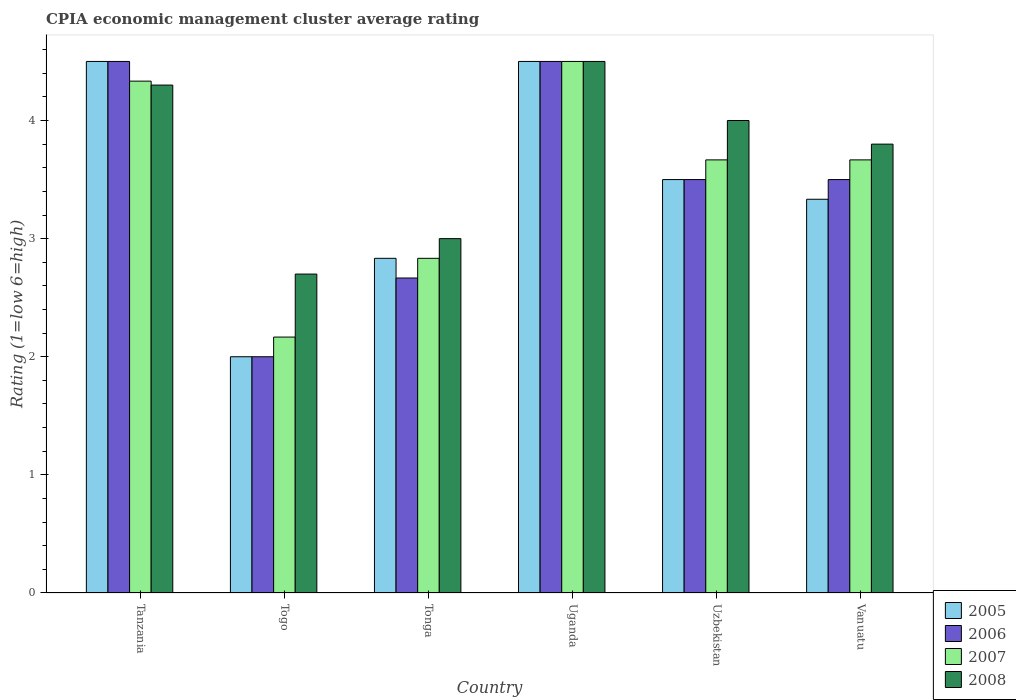How many groups of bars are there?
Give a very brief answer. 6. Are the number of bars per tick equal to the number of legend labels?
Your answer should be very brief. Yes. Are the number of bars on each tick of the X-axis equal?
Ensure brevity in your answer.  Yes. How many bars are there on the 3rd tick from the right?
Give a very brief answer. 4. What is the label of the 5th group of bars from the left?
Offer a terse response. Uzbekistan. What is the CPIA rating in 2005 in Uganda?
Offer a terse response. 4.5. Across all countries, what is the maximum CPIA rating in 2005?
Keep it short and to the point. 4.5. Across all countries, what is the minimum CPIA rating in 2008?
Your answer should be very brief. 2.7. In which country was the CPIA rating in 2006 maximum?
Make the answer very short. Tanzania. In which country was the CPIA rating in 2006 minimum?
Your answer should be compact. Togo. What is the total CPIA rating in 2005 in the graph?
Provide a succinct answer. 20.67. What is the difference between the CPIA rating in 2005 in Tonga and the CPIA rating in 2008 in Tanzania?
Keep it short and to the point. -1.47. What is the average CPIA rating in 2007 per country?
Your response must be concise. 3.53. What is the difference between the CPIA rating of/in 2008 and CPIA rating of/in 2007 in Vanuatu?
Provide a short and direct response. 0.13. What is the ratio of the CPIA rating in 2008 in Uzbekistan to that in Vanuatu?
Your answer should be very brief. 1.05. Is the difference between the CPIA rating in 2008 in Uganda and Vanuatu greater than the difference between the CPIA rating in 2007 in Uganda and Vanuatu?
Give a very brief answer. No. What is the difference between the highest and the lowest CPIA rating in 2007?
Make the answer very short. 2.33. Is the sum of the CPIA rating in 2007 in Togo and Vanuatu greater than the maximum CPIA rating in 2005 across all countries?
Offer a very short reply. Yes. Is it the case that in every country, the sum of the CPIA rating in 2005 and CPIA rating in 2008 is greater than the sum of CPIA rating in 2007 and CPIA rating in 2006?
Offer a very short reply. No. What does the 3rd bar from the right in Uganda represents?
Your answer should be very brief. 2006. How many bars are there?
Offer a very short reply. 24. Are the values on the major ticks of Y-axis written in scientific E-notation?
Give a very brief answer. No. Does the graph contain any zero values?
Offer a terse response. No. Does the graph contain grids?
Provide a succinct answer. No. Where does the legend appear in the graph?
Provide a short and direct response. Bottom right. What is the title of the graph?
Provide a short and direct response. CPIA economic management cluster average rating. Does "1990" appear as one of the legend labels in the graph?
Give a very brief answer. No. What is the label or title of the X-axis?
Give a very brief answer. Country. What is the Rating (1=low 6=high) in 2005 in Tanzania?
Offer a terse response. 4.5. What is the Rating (1=low 6=high) of 2007 in Tanzania?
Keep it short and to the point. 4.33. What is the Rating (1=low 6=high) in 2007 in Togo?
Your answer should be compact. 2.17. What is the Rating (1=low 6=high) of 2008 in Togo?
Give a very brief answer. 2.7. What is the Rating (1=low 6=high) in 2005 in Tonga?
Your answer should be very brief. 2.83. What is the Rating (1=low 6=high) of 2006 in Tonga?
Offer a very short reply. 2.67. What is the Rating (1=low 6=high) of 2007 in Tonga?
Provide a succinct answer. 2.83. What is the Rating (1=low 6=high) in 2005 in Uganda?
Ensure brevity in your answer.  4.5. What is the Rating (1=low 6=high) of 2006 in Uganda?
Offer a terse response. 4.5. What is the Rating (1=low 6=high) in 2005 in Uzbekistan?
Give a very brief answer. 3.5. What is the Rating (1=low 6=high) of 2006 in Uzbekistan?
Give a very brief answer. 3.5. What is the Rating (1=low 6=high) of 2007 in Uzbekistan?
Your response must be concise. 3.67. What is the Rating (1=low 6=high) of 2005 in Vanuatu?
Ensure brevity in your answer.  3.33. What is the Rating (1=low 6=high) of 2007 in Vanuatu?
Your response must be concise. 3.67. Across all countries, what is the maximum Rating (1=low 6=high) in 2006?
Offer a terse response. 4.5. Across all countries, what is the minimum Rating (1=low 6=high) of 2007?
Provide a succinct answer. 2.17. Across all countries, what is the minimum Rating (1=low 6=high) of 2008?
Offer a terse response. 2.7. What is the total Rating (1=low 6=high) of 2005 in the graph?
Make the answer very short. 20.67. What is the total Rating (1=low 6=high) in 2006 in the graph?
Your answer should be compact. 20.67. What is the total Rating (1=low 6=high) in 2007 in the graph?
Your answer should be very brief. 21.17. What is the total Rating (1=low 6=high) in 2008 in the graph?
Provide a short and direct response. 22.3. What is the difference between the Rating (1=low 6=high) of 2007 in Tanzania and that in Togo?
Make the answer very short. 2.17. What is the difference between the Rating (1=low 6=high) of 2008 in Tanzania and that in Togo?
Your answer should be very brief. 1.6. What is the difference between the Rating (1=low 6=high) in 2005 in Tanzania and that in Tonga?
Ensure brevity in your answer.  1.67. What is the difference between the Rating (1=low 6=high) of 2006 in Tanzania and that in Tonga?
Provide a short and direct response. 1.83. What is the difference between the Rating (1=low 6=high) of 2008 in Tanzania and that in Tonga?
Offer a terse response. 1.3. What is the difference between the Rating (1=low 6=high) of 2007 in Tanzania and that in Uganda?
Make the answer very short. -0.17. What is the difference between the Rating (1=low 6=high) in 2008 in Tanzania and that in Uganda?
Your response must be concise. -0.2. What is the difference between the Rating (1=low 6=high) of 2005 in Tanzania and that in Uzbekistan?
Offer a terse response. 1. What is the difference between the Rating (1=low 6=high) of 2008 in Tanzania and that in Uzbekistan?
Ensure brevity in your answer.  0.3. What is the difference between the Rating (1=low 6=high) in 2006 in Togo and that in Tonga?
Your answer should be compact. -0.67. What is the difference between the Rating (1=low 6=high) in 2007 in Togo and that in Uganda?
Keep it short and to the point. -2.33. What is the difference between the Rating (1=low 6=high) in 2006 in Togo and that in Uzbekistan?
Keep it short and to the point. -1.5. What is the difference between the Rating (1=low 6=high) in 2007 in Togo and that in Uzbekistan?
Your response must be concise. -1.5. What is the difference between the Rating (1=low 6=high) of 2008 in Togo and that in Uzbekistan?
Give a very brief answer. -1.3. What is the difference between the Rating (1=low 6=high) in 2005 in Togo and that in Vanuatu?
Ensure brevity in your answer.  -1.33. What is the difference between the Rating (1=low 6=high) in 2006 in Togo and that in Vanuatu?
Provide a short and direct response. -1.5. What is the difference between the Rating (1=low 6=high) of 2005 in Tonga and that in Uganda?
Ensure brevity in your answer.  -1.67. What is the difference between the Rating (1=low 6=high) in 2006 in Tonga and that in Uganda?
Offer a very short reply. -1.83. What is the difference between the Rating (1=low 6=high) of 2007 in Tonga and that in Uganda?
Your response must be concise. -1.67. What is the difference between the Rating (1=low 6=high) in 2008 in Tonga and that in Uganda?
Give a very brief answer. -1.5. What is the difference between the Rating (1=low 6=high) of 2007 in Tonga and that in Uzbekistan?
Your answer should be very brief. -0.83. What is the difference between the Rating (1=low 6=high) in 2005 in Tonga and that in Vanuatu?
Keep it short and to the point. -0.5. What is the difference between the Rating (1=low 6=high) of 2006 in Tonga and that in Vanuatu?
Ensure brevity in your answer.  -0.83. What is the difference between the Rating (1=low 6=high) of 2007 in Tonga and that in Vanuatu?
Your answer should be very brief. -0.83. What is the difference between the Rating (1=low 6=high) of 2006 in Uganda and that in Uzbekistan?
Your response must be concise. 1. What is the difference between the Rating (1=low 6=high) in 2008 in Uganda and that in Uzbekistan?
Offer a very short reply. 0.5. What is the difference between the Rating (1=low 6=high) in 2005 in Uganda and that in Vanuatu?
Provide a succinct answer. 1.17. What is the difference between the Rating (1=low 6=high) in 2007 in Uganda and that in Vanuatu?
Ensure brevity in your answer.  0.83. What is the difference between the Rating (1=low 6=high) in 2005 in Tanzania and the Rating (1=low 6=high) in 2007 in Togo?
Give a very brief answer. 2.33. What is the difference between the Rating (1=low 6=high) in 2006 in Tanzania and the Rating (1=low 6=high) in 2007 in Togo?
Ensure brevity in your answer.  2.33. What is the difference between the Rating (1=low 6=high) in 2007 in Tanzania and the Rating (1=low 6=high) in 2008 in Togo?
Your answer should be very brief. 1.63. What is the difference between the Rating (1=low 6=high) of 2005 in Tanzania and the Rating (1=low 6=high) of 2006 in Tonga?
Your answer should be very brief. 1.83. What is the difference between the Rating (1=low 6=high) in 2006 in Tanzania and the Rating (1=low 6=high) in 2007 in Tonga?
Provide a short and direct response. 1.67. What is the difference between the Rating (1=low 6=high) of 2006 in Tanzania and the Rating (1=low 6=high) of 2008 in Tonga?
Offer a very short reply. 1.5. What is the difference between the Rating (1=low 6=high) of 2007 in Tanzania and the Rating (1=low 6=high) of 2008 in Tonga?
Provide a succinct answer. 1.33. What is the difference between the Rating (1=low 6=high) in 2005 in Tanzania and the Rating (1=low 6=high) in 2006 in Uganda?
Provide a short and direct response. 0. What is the difference between the Rating (1=low 6=high) in 2006 in Tanzania and the Rating (1=low 6=high) in 2007 in Uganda?
Ensure brevity in your answer.  0. What is the difference between the Rating (1=low 6=high) in 2005 in Tanzania and the Rating (1=low 6=high) in 2006 in Uzbekistan?
Your answer should be very brief. 1. What is the difference between the Rating (1=low 6=high) of 2005 in Tanzania and the Rating (1=low 6=high) of 2008 in Uzbekistan?
Ensure brevity in your answer.  0.5. What is the difference between the Rating (1=low 6=high) of 2006 in Tanzania and the Rating (1=low 6=high) of 2008 in Uzbekistan?
Your answer should be compact. 0.5. What is the difference between the Rating (1=low 6=high) of 2005 in Tanzania and the Rating (1=low 6=high) of 2008 in Vanuatu?
Provide a succinct answer. 0.7. What is the difference between the Rating (1=low 6=high) in 2006 in Tanzania and the Rating (1=low 6=high) in 2008 in Vanuatu?
Keep it short and to the point. 0.7. What is the difference between the Rating (1=low 6=high) of 2007 in Tanzania and the Rating (1=low 6=high) of 2008 in Vanuatu?
Provide a short and direct response. 0.53. What is the difference between the Rating (1=low 6=high) in 2005 in Togo and the Rating (1=low 6=high) in 2006 in Tonga?
Make the answer very short. -0.67. What is the difference between the Rating (1=low 6=high) of 2005 in Togo and the Rating (1=low 6=high) of 2007 in Tonga?
Provide a succinct answer. -0.83. What is the difference between the Rating (1=low 6=high) of 2007 in Togo and the Rating (1=low 6=high) of 2008 in Tonga?
Ensure brevity in your answer.  -0.83. What is the difference between the Rating (1=low 6=high) in 2005 in Togo and the Rating (1=low 6=high) in 2008 in Uganda?
Your response must be concise. -2.5. What is the difference between the Rating (1=low 6=high) in 2007 in Togo and the Rating (1=low 6=high) in 2008 in Uganda?
Your response must be concise. -2.33. What is the difference between the Rating (1=low 6=high) in 2005 in Togo and the Rating (1=low 6=high) in 2006 in Uzbekistan?
Give a very brief answer. -1.5. What is the difference between the Rating (1=low 6=high) in 2005 in Togo and the Rating (1=low 6=high) in 2007 in Uzbekistan?
Your answer should be very brief. -1.67. What is the difference between the Rating (1=low 6=high) of 2005 in Togo and the Rating (1=low 6=high) of 2008 in Uzbekistan?
Your answer should be very brief. -2. What is the difference between the Rating (1=low 6=high) in 2006 in Togo and the Rating (1=low 6=high) in 2007 in Uzbekistan?
Give a very brief answer. -1.67. What is the difference between the Rating (1=low 6=high) in 2006 in Togo and the Rating (1=low 6=high) in 2008 in Uzbekistan?
Your answer should be very brief. -2. What is the difference between the Rating (1=low 6=high) of 2007 in Togo and the Rating (1=low 6=high) of 2008 in Uzbekistan?
Offer a terse response. -1.83. What is the difference between the Rating (1=low 6=high) of 2005 in Togo and the Rating (1=low 6=high) of 2006 in Vanuatu?
Keep it short and to the point. -1.5. What is the difference between the Rating (1=low 6=high) of 2005 in Togo and the Rating (1=low 6=high) of 2007 in Vanuatu?
Your answer should be very brief. -1.67. What is the difference between the Rating (1=low 6=high) in 2005 in Togo and the Rating (1=low 6=high) in 2008 in Vanuatu?
Ensure brevity in your answer.  -1.8. What is the difference between the Rating (1=low 6=high) of 2006 in Togo and the Rating (1=low 6=high) of 2007 in Vanuatu?
Give a very brief answer. -1.67. What is the difference between the Rating (1=low 6=high) of 2007 in Togo and the Rating (1=low 6=high) of 2008 in Vanuatu?
Keep it short and to the point. -1.63. What is the difference between the Rating (1=low 6=high) in 2005 in Tonga and the Rating (1=low 6=high) in 2006 in Uganda?
Make the answer very short. -1.67. What is the difference between the Rating (1=low 6=high) in 2005 in Tonga and the Rating (1=low 6=high) in 2007 in Uganda?
Ensure brevity in your answer.  -1.67. What is the difference between the Rating (1=low 6=high) in 2005 in Tonga and the Rating (1=low 6=high) in 2008 in Uganda?
Provide a succinct answer. -1.67. What is the difference between the Rating (1=low 6=high) in 2006 in Tonga and the Rating (1=low 6=high) in 2007 in Uganda?
Give a very brief answer. -1.83. What is the difference between the Rating (1=low 6=high) of 2006 in Tonga and the Rating (1=low 6=high) of 2008 in Uganda?
Your answer should be compact. -1.83. What is the difference between the Rating (1=low 6=high) of 2007 in Tonga and the Rating (1=low 6=high) of 2008 in Uganda?
Ensure brevity in your answer.  -1.67. What is the difference between the Rating (1=low 6=high) of 2005 in Tonga and the Rating (1=low 6=high) of 2006 in Uzbekistan?
Provide a succinct answer. -0.67. What is the difference between the Rating (1=low 6=high) in 2005 in Tonga and the Rating (1=low 6=high) in 2008 in Uzbekistan?
Make the answer very short. -1.17. What is the difference between the Rating (1=low 6=high) of 2006 in Tonga and the Rating (1=low 6=high) of 2007 in Uzbekistan?
Your answer should be very brief. -1. What is the difference between the Rating (1=low 6=high) in 2006 in Tonga and the Rating (1=low 6=high) in 2008 in Uzbekistan?
Your response must be concise. -1.33. What is the difference between the Rating (1=low 6=high) of 2007 in Tonga and the Rating (1=low 6=high) of 2008 in Uzbekistan?
Give a very brief answer. -1.17. What is the difference between the Rating (1=low 6=high) of 2005 in Tonga and the Rating (1=low 6=high) of 2007 in Vanuatu?
Make the answer very short. -0.83. What is the difference between the Rating (1=low 6=high) of 2005 in Tonga and the Rating (1=low 6=high) of 2008 in Vanuatu?
Provide a short and direct response. -0.97. What is the difference between the Rating (1=low 6=high) in 2006 in Tonga and the Rating (1=low 6=high) in 2008 in Vanuatu?
Provide a succinct answer. -1.13. What is the difference between the Rating (1=low 6=high) of 2007 in Tonga and the Rating (1=low 6=high) of 2008 in Vanuatu?
Offer a very short reply. -0.97. What is the difference between the Rating (1=low 6=high) in 2005 in Uganda and the Rating (1=low 6=high) in 2006 in Uzbekistan?
Give a very brief answer. 1. What is the difference between the Rating (1=low 6=high) of 2007 in Uganda and the Rating (1=low 6=high) of 2008 in Uzbekistan?
Make the answer very short. 0.5. What is the difference between the Rating (1=low 6=high) of 2005 in Uganda and the Rating (1=low 6=high) of 2007 in Vanuatu?
Keep it short and to the point. 0.83. What is the difference between the Rating (1=low 6=high) in 2005 in Uganda and the Rating (1=low 6=high) in 2008 in Vanuatu?
Provide a short and direct response. 0.7. What is the difference between the Rating (1=low 6=high) of 2006 in Uganda and the Rating (1=low 6=high) of 2008 in Vanuatu?
Provide a short and direct response. 0.7. What is the difference between the Rating (1=low 6=high) in 2005 in Uzbekistan and the Rating (1=low 6=high) in 2008 in Vanuatu?
Make the answer very short. -0.3. What is the difference between the Rating (1=low 6=high) in 2006 in Uzbekistan and the Rating (1=low 6=high) in 2007 in Vanuatu?
Ensure brevity in your answer.  -0.17. What is the difference between the Rating (1=low 6=high) of 2006 in Uzbekistan and the Rating (1=low 6=high) of 2008 in Vanuatu?
Provide a succinct answer. -0.3. What is the difference between the Rating (1=low 6=high) of 2007 in Uzbekistan and the Rating (1=low 6=high) of 2008 in Vanuatu?
Offer a very short reply. -0.13. What is the average Rating (1=low 6=high) in 2005 per country?
Provide a short and direct response. 3.44. What is the average Rating (1=low 6=high) in 2006 per country?
Make the answer very short. 3.44. What is the average Rating (1=low 6=high) in 2007 per country?
Your answer should be compact. 3.53. What is the average Rating (1=low 6=high) in 2008 per country?
Provide a succinct answer. 3.72. What is the difference between the Rating (1=low 6=high) in 2005 and Rating (1=low 6=high) in 2006 in Tanzania?
Provide a short and direct response. 0. What is the difference between the Rating (1=low 6=high) of 2005 and Rating (1=low 6=high) of 2008 in Tanzania?
Make the answer very short. 0.2. What is the difference between the Rating (1=low 6=high) of 2006 and Rating (1=low 6=high) of 2007 in Tanzania?
Offer a very short reply. 0.17. What is the difference between the Rating (1=low 6=high) of 2006 and Rating (1=low 6=high) of 2008 in Tanzania?
Ensure brevity in your answer.  0.2. What is the difference between the Rating (1=low 6=high) of 2007 and Rating (1=low 6=high) of 2008 in Tanzania?
Your answer should be very brief. 0.03. What is the difference between the Rating (1=low 6=high) in 2006 and Rating (1=low 6=high) in 2007 in Togo?
Give a very brief answer. -0.17. What is the difference between the Rating (1=low 6=high) of 2006 and Rating (1=low 6=high) of 2008 in Togo?
Offer a terse response. -0.7. What is the difference between the Rating (1=low 6=high) in 2007 and Rating (1=low 6=high) in 2008 in Togo?
Your response must be concise. -0.53. What is the difference between the Rating (1=low 6=high) of 2005 and Rating (1=low 6=high) of 2006 in Tonga?
Offer a very short reply. 0.17. What is the difference between the Rating (1=low 6=high) of 2005 and Rating (1=low 6=high) of 2007 in Tonga?
Make the answer very short. 0. What is the difference between the Rating (1=low 6=high) of 2005 and Rating (1=low 6=high) of 2008 in Tonga?
Provide a succinct answer. -0.17. What is the difference between the Rating (1=low 6=high) of 2006 and Rating (1=low 6=high) of 2008 in Tonga?
Make the answer very short. -0.33. What is the difference between the Rating (1=low 6=high) in 2005 and Rating (1=low 6=high) in 2007 in Uganda?
Your answer should be compact. 0. What is the difference between the Rating (1=low 6=high) in 2006 and Rating (1=low 6=high) in 2007 in Uganda?
Make the answer very short. 0. What is the difference between the Rating (1=low 6=high) of 2006 and Rating (1=low 6=high) of 2008 in Uganda?
Provide a short and direct response. 0. What is the difference between the Rating (1=low 6=high) in 2007 and Rating (1=low 6=high) in 2008 in Uganda?
Ensure brevity in your answer.  0. What is the difference between the Rating (1=low 6=high) in 2005 and Rating (1=low 6=high) in 2006 in Uzbekistan?
Your response must be concise. 0. What is the difference between the Rating (1=low 6=high) in 2005 and Rating (1=low 6=high) in 2007 in Uzbekistan?
Your answer should be compact. -0.17. What is the difference between the Rating (1=low 6=high) in 2005 and Rating (1=low 6=high) in 2008 in Uzbekistan?
Provide a succinct answer. -0.5. What is the difference between the Rating (1=low 6=high) of 2006 and Rating (1=low 6=high) of 2007 in Uzbekistan?
Ensure brevity in your answer.  -0.17. What is the difference between the Rating (1=low 6=high) of 2005 and Rating (1=low 6=high) of 2008 in Vanuatu?
Provide a short and direct response. -0.47. What is the difference between the Rating (1=low 6=high) in 2007 and Rating (1=low 6=high) in 2008 in Vanuatu?
Provide a succinct answer. -0.13. What is the ratio of the Rating (1=low 6=high) of 2005 in Tanzania to that in Togo?
Your response must be concise. 2.25. What is the ratio of the Rating (1=low 6=high) in 2006 in Tanzania to that in Togo?
Make the answer very short. 2.25. What is the ratio of the Rating (1=low 6=high) in 2007 in Tanzania to that in Togo?
Your answer should be compact. 2. What is the ratio of the Rating (1=low 6=high) of 2008 in Tanzania to that in Togo?
Keep it short and to the point. 1.59. What is the ratio of the Rating (1=low 6=high) in 2005 in Tanzania to that in Tonga?
Your answer should be very brief. 1.59. What is the ratio of the Rating (1=low 6=high) of 2006 in Tanzania to that in Tonga?
Keep it short and to the point. 1.69. What is the ratio of the Rating (1=low 6=high) in 2007 in Tanzania to that in Tonga?
Offer a very short reply. 1.53. What is the ratio of the Rating (1=low 6=high) in 2008 in Tanzania to that in Tonga?
Make the answer very short. 1.43. What is the ratio of the Rating (1=low 6=high) in 2006 in Tanzania to that in Uganda?
Your answer should be compact. 1. What is the ratio of the Rating (1=low 6=high) in 2007 in Tanzania to that in Uganda?
Give a very brief answer. 0.96. What is the ratio of the Rating (1=low 6=high) in 2008 in Tanzania to that in Uganda?
Offer a very short reply. 0.96. What is the ratio of the Rating (1=low 6=high) in 2007 in Tanzania to that in Uzbekistan?
Offer a very short reply. 1.18. What is the ratio of the Rating (1=low 6=high) in 2008 in Tanzania to that in Uzbekistan?
Keep it short and to the point. 1.07. What is the ratio of the Rating (1=low 6=high) of 2005 in Tanzania to that in Vanuatu?
Give a very brief answer. 1.35. What is the ratio of the Rating (1=low 6=high) of 2006 in Tanzania to that in Vanuatu?
Offer a terse response. 1.29. What is the ratio of the Rating (1=low 6=high) in 2007 in Tanzania to that in Vanuatu?
Provide a succinct answer. 1.18. What is the ratio of the Rating (1=low 6=high) of 2008 in Tanzania to that in Vanuatu?
Offer a very short reply. 1.13. What is the ratio of the Rating (1=low 6=high) of 2005 in Togo to that in Tonga?
Your answer should be compact. 0.71. What is the ratio of the Rating (1=low 6=high) of 2007 in Togo to that in Tonga?
Your answer should be very brief. 0.76. What is the ratio of the Rating (1=low 6=high) in 2008 in Togo to that in Tonga?
Your answer should be very brief. 0.9. What is the ratio of the Rating (1=low 6=high) of 2005 in Togo to that in Uganda?
Your answer should be compact. 0.44. What is the ratio of the Rating (1=low 6=high) of 2006 in Togo to that in Uganda?
Make the answer very short. 0.44. What is the ratio of the Rating (1=low 6=high) of 2007 in Togo to that in Uganda?
Ensure brevity in your answer.  0.48. What is the ratio of the Rating (1=low 6=high) of 2008 in Togo to that in Uganda?
Offer a terse response. 0.6. What is the ratio of the Rating (1=low 6=high) of 2006 in Togo to that in Uzbekistan?
Keep it short and to the point. 0.57. What is the ratio of the Rating (1=low 6=high) of 2007 in Togo to that in Uzbekistan?
Provide a succinct answer. 0.59. What is the ratio of the Rating (1=low 6=high) in 2008 in Togo to that in Uzbekistan?
Provide a succinct answer. 0.68. What is the ratio of the Rating (1=low 6=high) in 2005 in Togo to that in Vanuatu?
Give a very brief answer. 0.6. What is the ratio of the Rating (1=low 6=high) of 2007 in Togo to that in Vanuatu?
Provide a short and direct response. 0.59. What is the ratio of the Rating (1=low 6=high) of 2008 in Togo to that in Vanuatu?
Your answer should be very brief. 0.71. What is the ratio of the Rating (1=low 6=high) of 2005 in Tonga to that in Uganda?
Give a very brief answer. 0.63. What is the ratio of the Rating (1=low 6=high) in 2006 in Tonga to that in Uganda?
Give a very brief answer. 0.59. What is the ratio of the Rating (1=low 6=high) of 2007 in Tonga to that in Uganda?
Your response must be concise. 0.63. What is the ratio of the Rating (1=low 6=high) in 2008 in Tonga to that in Uganda?
Offer a terse response. 0.67. What is the ratio of the Rating (1=low 6=high) of 2005 in Tonga to that in Uzbekistan?
Ensure brevity in your answer.  0.81. What is the ratio of the Rating (1=low 6=high) of 2006 in Tonga to that in Uzbekistan?
Your response must be concise. 0.76. What is the ratio of the Rating (1=low 6=high) of 2007 in Tonga to that in Uzbekistan?
Make the answer very short. 0.77. What is the ratio of the Rating (1=low 6=high) of 2005 in Tonga to that in Vanuatu?
Your response must be concise. 0.85. What is the ratio of the Rating (1=low 6=high) of 2006 in Tonga to that in Vanuatu?
Offer a terse response. 0.76. What is the ratio of the Rating (1=low 6=high) in 2007 in Tonga to that in Vanuatu?
Provide a short and direct response. 0.77. What is the ratio of the Rating (1=low 6=high) of 2008 in Tonga to that in Vanuatu?
Keep it short and to the point. 0.79. What is the ratio of the Rating (1=low 6=high) of 2007 in Uganda to that in Uzbekistan?
Offer a very short reply. 1.23. What is the ratio of the Rating (1=low 6=high) in 2005 in Uganda to that in Vanuatu?
Your answer should be very brief. 1.35. What is the ratio of the Rating (1=low 6=high) in 2006 in Uganda to that in Vanuatu?
Your answer should be compact. 1.29. What is the ratio of the Rating (1=low 6=high) of 2007 in Uganda to that in Vanuatu?
Your response must be concise. 1.23. What is the ratio of the Rating (1=low 6=high) of 2008 in Uganda to that in Vanuatu?
Ensure brevity in your answer.  1.18. What is the ratio of the Rating (1=low 6=high) in 2006 in Uzbekistan to that in Vanuatu?
Your answer should be compact. 1. What is the ratio of the Rating (1=low 6=high) of 2008 in Uzbekistan to that in Vanuatu?
Your answer should be very brief. 1.05. What is the difference between the highest and the lowest Rating (1=low 6=high) in 2006?
Offer a terse response. 2.5. What is the difference between the highest and the lowest Rating (1=low 6=high) in 2007?
Make the answer very short. 2.33. What is the difference between the highest and the lowest Rating (1=low 6=high) of 2008?
Your answer should be compact. 1.8. 